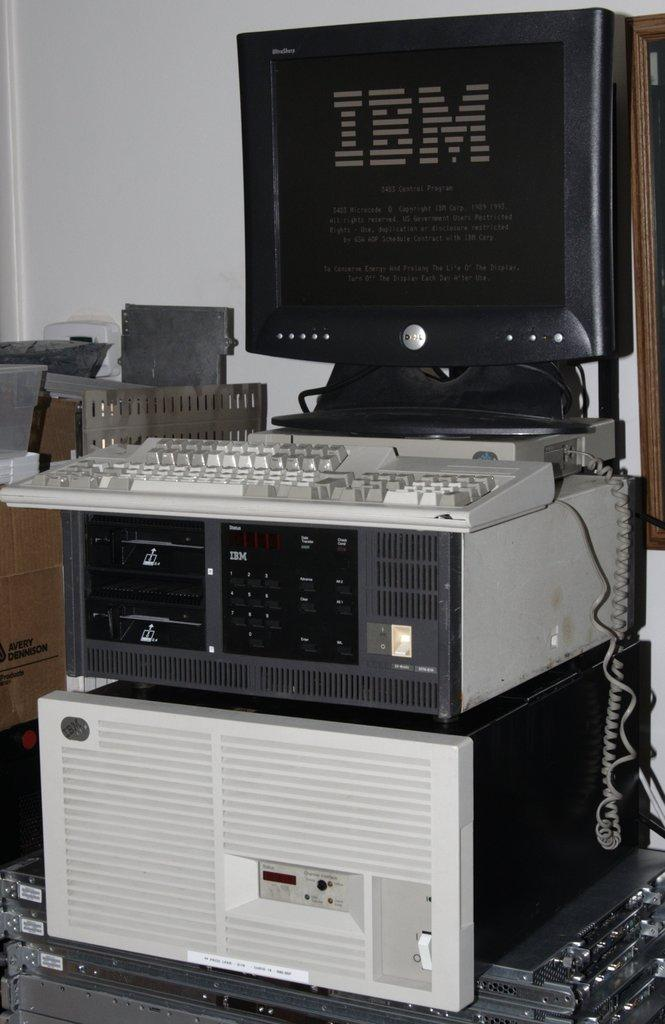<image>
Offer a succinct explanation of the picture presented. A computer monitor that displays the name of the company IBM. 